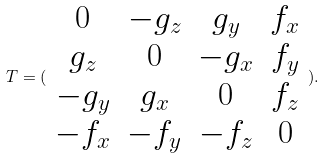<formula> <loc_0><loc_0><loc_500><loc_500>T = ( \begin{array} { c c c c } 0 & - g _ { z } & g _ { y } & f _ { x } \\ g _ { z } & 0 & - g _ { x } & f _ { y } \\ - g _ { y } & g _ { x } & 0 & f _ { z } \\ - f _ { x } & - f _ { y } & - f _ { z } & 0 \end{array} ) .</formula> 